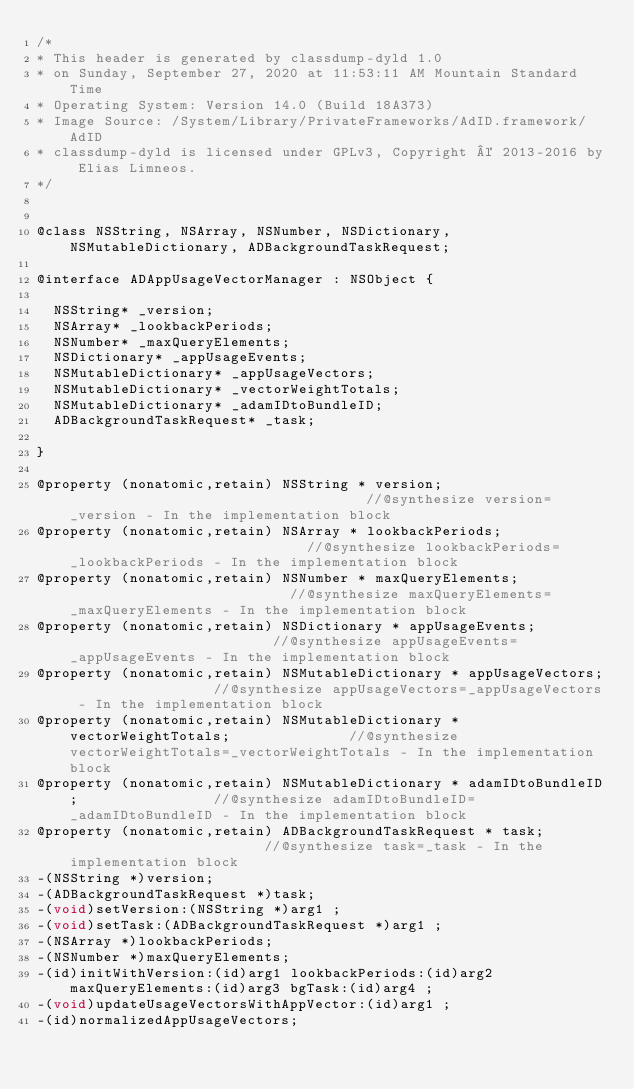<code> <loc_0><loc_0><loc_500><loc_500><_C_>/*
* This header is generated by classdump-dyld 1.0
* on Sunday, September 27, 2020 at 11:53:11 AM Mountain Standard Time
* Operating System: Version 14.0 (Build 18A373)
* Image Source: /System/Library/PrivateFrameworks/AdID.framework/AdID
* classdump-dyld is licensed under GPLv3, Copyright © 2013-2016 by Elias Limneos.
*/


@class NSString, NSArray, NSNumber, NSDictionary, NSMutableDictionary, ADBackgroundTaskRequest;

@interface ADAppUsageVectorManager : NSObject {

	NSString* _version;
	NSArray* _lookbackPeriods;
	NSNumber* _maxQueryElements;
	NSDictionary* _appUsageEvents;
	NSMutableDictionary* _appUsageVectors;
	NSMutableDictionary* _vectorWeightTotals;
	NSMutableDictionary* _adamIDtoBundleID;
	ADBackgroundTaskRequest* _task;

}

@property (nonatomic,retain) NSString * version;                                    //@synthesize version=_version - In the implementation block
@property (nonatomic,retain) NSArray * lookbackPeriods;                             //@synthesize lookbackPeriods=_lookbackPeriods - In the implementation block
@property (nonatomic,retain) NSNumber * maxQueryElements;                           //@synthesize maxQueryElements=_maxQueryElements - In the implementation block
@property (nonatomic,retain) NSDictionary * appUsageEvents;                         //@synthesize appUsageEvents=_appUsageEvents - In the implementation block
@property (nonatomic,retain) NSMutableDictionary * appUsageVectors;                 //@synthesize appUsageVectors=_appUsageVectors - In the implementation block
@property (nonatomic,retain) NSMutableDictionary * vectorWeightTotals;              //@synthesize vectorWeightTotals=_vectorWeightTotals - In the implementation block
@property (nonatomic,retain) NSMutableDictionary * adamIDtoBundleID;                //@synthesize adamIDtoBundleID=_adamIDtoBundleID - In the implementation block
@property (nonatomic,retain) ADBackgroundTaskRequest * task;                        //@synthesize task=_task - In the implementation block
-(NSString *)version;
-(ADBackgroundTaskRequest *)task;
-(void)setVersion:(NSString *)arg1 ;
-(void)setTask:(ADBackgroundTaskRequest *)arg1 ;
-(NSArray *)lookbackPeriods;
-(NSNumber *)maxQueryElements;
-(id)initWithVersion:(id)arg1 lookbackPeriods:(id)arg2 maxQueryElements:(id)arg3 bgTask:(id)arg4 ;
-(void)updateUsageVectorsWithAppVector:(id)arg1 ;
-(id)normalizedAppUsageVectors;</code> 